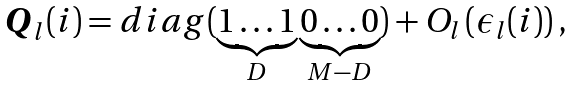Convert formula to latex. <formula><loc_0><loc_0><loc_500><loc_500>\boldsymbol Q _ { l } ( i ) = d i a g ( \underbrace { 1 \dots 1 } _ { D } \underbrace { 0 \dots 0 } _ { M - D } ) + O _ { l } \left ( \epsilon _ { l } ( i ) \right ) ,</formula> 